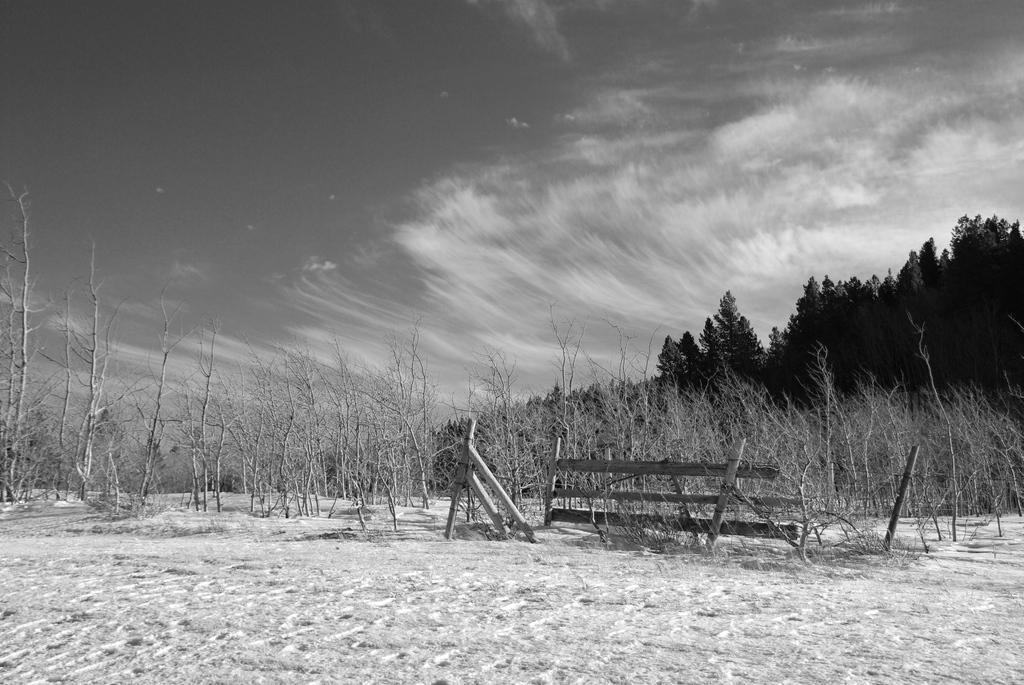What is located in the center of the image? There are dry plants in the center of the image. What can be seen in the background of the image? There are trees in the background of the image. How would you describe the sky in the image? The sky is cloudy in the image. How many flowers are on the lift in the image? There is no lift present in the image, and therefore no flowers on a lift can be observed. 